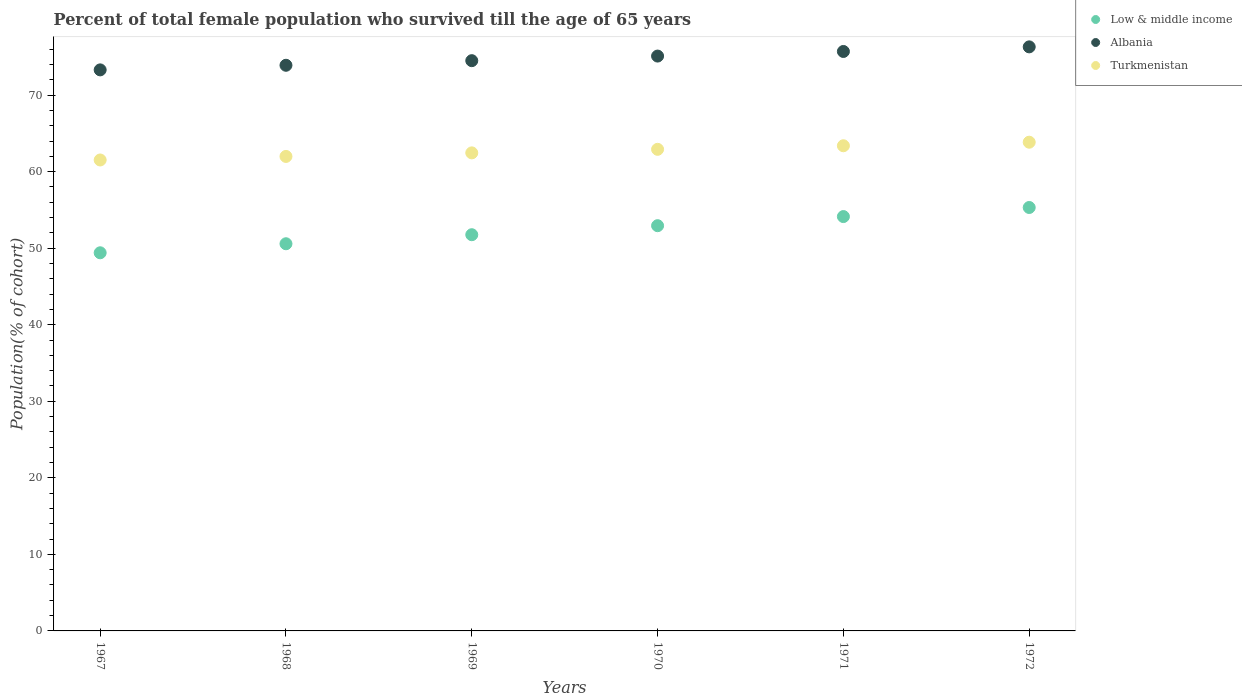How many different coloured dotlines are there?
Your answer should be compact. 3. Is the number of dotlines equal to the number of legend labels?
Make the answer very short. Yes. What is the percentage of total female population who survived till the age of 65 years in Low & middle income in 1969?
Offer a very short reply. 51.76. Across all years, what is the maximum percentage of total female population who survived till the age of 65 years in Albania?
Your answer should be compact. 76.3. Across all years, what is the minimum percentage of total female population who survived till the age of 65 years in Low & middle income?
Provide a short and direct response. 49.4. In which year was the percentage of total female population who survived till the age of 65 years in Turkmenistan maximum?
Make the answer very short. 1972. In which year was the percentage of total female population who survived till the age of 65 years in Turkmenistan minimum?
Offer a terse response. 1967. What is the total percentage of total female population who survived till the age of 65 years in Albania in the graph?
Offer a very short reply. 448.81. What is the difference between the percentage of total female population who survived till the age of 65 years in Turkmenistan in 1967 and that in 1970?
Offer a very short reply. -1.39. What is the difference between the percentage of total female population who survived till the age of 65 years in Albania in 1967 and the percentage of total female population who survived till the age of 65 years in Low & middle income in 1968?
Offer a terse response. 22.72. What is the average percentage of total female population who survived till the age of 65 years in Turkmenistan per year?
Give a very brief answer. 62.69. In the year 1967, what is the difference between the percentage of total female population who survived till the age of 65 years in Turkmenistan and percentage of total female population who survived till the age of 65 years in Albania?
Offer a terse response. -11.77. What is the ratio of the percentage of total female population who survived till the age of 65 years in Albania in 1967 to that in 1968?
Ensure brevity in your answer.  0.99. Is the percentage of total female population who survived till the age of 65 years in Turkmenistan in 1969 less than that in 1972?
Your response must be concise. Yes. Is the difference between the percentage of total female population who survived till the age of 65 years in Turkmenistan in 1970 and 1971 greater than the difference between the percentage of total female population who survived till the age of 65 years in Albania in 1970 and 1971?
Provide a short and direct response. Yes. What is the difference between the highest and the second highest percentage of total female population who survived till the age of 65 years in Albania?
Keep it short and to the point. 0.6. What is the difference between the highest and the lowest percentage of total female population who survived till the age of 65 years in Albania?
Give a very brief answer. 3.01. In how many years, is the percentage of total female population who survived till the age of 65 years in Albania greater than the average percentage of total female population who survived till the age of 65 years in Albania taken over all years?
Your answer should be very brief. 3. Is the sum of the percentage of total female population who survived till the age of 65 years in Albania in 1967 and 1968 greater than the maximum percentage of total female population who survived till the age of 65 years in Low & middle income across all years?
Ensure brevity in your answer.  Yes. Is it the case that in every year, the sum of the percentage of total female population who survived till the age of 65 years in Turkmenistan and percentage of total female population who survived till the age of 65 years in Low & middle income  is greater than the percentage of total female population who survived till the age of 65 years in Albania?
Give a very brief answer. Yes. Does the percentage of total female population who survived till the age of 65 years in Low & middle income monotonically increase over the years?
Keep it short and to the point. Yes. How many years are there in the graph?
Offer a very short reply. 6. What is the difference between two consecutive major ticks on the Y-axis?
Make the answer very short. 10. Does the graph contain grids?
Keep it short and to the point. No. How are the legend labels stacked?
Your response must be concise. Vertical. What is the title of the graph?
Your answer should be compact. Percent of total female population who survived till the age of 65 years. What is the label or title of the X-axis?
Offer a very short reply. Years. What is the label or title of the Y-axis?
Offer a very short reply. Population(% of cohort). What is the Population(% of cohort) in Low & middle income in 1967?
Your response must be concise. 49.4. What is the Population(% of cohort) in Albania in 1967?
Offer a very short reply. 73.3. What is the Population(% of cohort) of Turkmenistan in 1967?
Your answer should be very brief. 61.53. What is the Population(% of cohort) of Low & middle income in 1968?
Your answer should be very brief. 50.58. What is the Population(% of cohort) of Albania in 1968?
Provide a short and direct response. 73.9. What is the Population(% of cohort) of Turkmenistan in 1968?
Your answer should be compact. 61.99. What is the Population(% of cohort) in Low & middle income in 1969?
Make the answer very short. 51.76. What is the Population(% of cohort) in Albania in 1969?
Your answer should be very brief. 74.5. What is the Population(% of cohort) in Turkmenistan in 1969?
Your response must be concise. 62.46. What is the Population(% of cohort) in Low & middle income in 1970?
Make the answer very short. 52.94. What is the Population(% of cohort) of Albania in 1970?
Keep it short and to the point. 75.1. What is the Population(% of cohort) in Turkmenistan in 1970?
Offer a terse response. 62.92. What is the Population(% of cohort) of Low & middle income in 1971?
Make the answer very short. 54.13. What is the Population(% of cohort) of Albania in 1971?
Make the answer very short. 75.7. What is the Population(% of cohort) in Turkmenistan in 1971?
Make the answer very short. 63.38. What is the Population(% of cohort) in Low & middle income in 1972?
Offer a terse response. 55.32. What is the Population(% of cohort) in Albania in 1972?
Your answer should be compact. 76.3. What is the Population(% of cohort) in Turkmenistan in 1972?
Keep it short and to the point. 63.85. Across all years, what is the maximum Population(% of cohort) of Low & middle income?
Keep it short and to the point. 55.32. Across all years, what is the maximum Population(% of cohort) of Albania?
Offer a very short reply. 76.3. Across all years, what is the maximum Population(% of cohort) of Turkmenistan?
Your answer should be compact. 63.85. Across all years, what is the minimum Population(% of cohort) in Low & middle income?
Give a very brief answer. 49.4. Across all years, what is the minimum Population(% of cohort) in Albania?
Ensure brevity in your answer.  73.3. Across all years, what is the minimum Population(% of cohort) of Turkmenistan?
Offer a terse response. 61.53. What is the total Population(% of cohort) of Low & middle income in the graph?
Offer a terse response. 314.14. What is the total Population(% of cohort) in Albania in the graph?
Keep it short and to the point. 448.81. What is the total Population(% of cohort) of Turkmenistan in the graph?
Give a very brief answer. 376.13. What is the difference between the Population(% of cohort) of Low & middle income in 1967 and that in 1968?
Make the answer very short. -1.18. What is the difference between the Population(% of cohort) in Albania in 1967 and that in 1968?
Your response must be concise. -0.6. What is the difference between the Population(% of cohort) of Turkmenistan in 1967 and that in 1968?
Make the answer very short. -0.46. What is the difference between the Population(% of cohort) of Low & middle income in 1967 and that in 1969?
Keep it short and to the point. -2.36. What is the difference between the Population(% of cohort) of Albania in 1967 and that in 1969?
Offer a terse response. -1.2. What is the difference between the Population(% of cohort) in Turkmenistan in 1967 and that in 1969?
Give a very brief answer. -0.93. What is the difference between the Population(% of cohort) in Low & middle income in 1967 and that in 1970?
Ensure brevity in your answer.  -3.54. What is the difference between the Population(% of cohort) of Albania in 1967 and that in 1970?
Ensure brevity in your answer.  -1.8. What is the difference between the Population(% of cohort) of Turkmenistan in 1967 and that in 1970?
Keep it short and to the point. -1.39. What is the difference between the Population(% of cohort) of Low & middle income in 1967 and that in 1971?
Keep it short and to the point. -4.73. What is the difference between the Population(% of cohort) in Albania in 1967 and that in 1971?
Make the answer very short. -2.4. What is the difference between the Population(% of cohort) of Turkmenistan in 1967 and that in 1971?
Your answer should be very brief. -1.86. What is the difference between the Population(% of cohort) in Low & middle income in 1967 and that in 1972?
Make the answer very short. -5.92. What is the difference between the Population(% of cohort) in Albania in 1967 and that in 1972?
Keep it short and to the point. -3.01. What is the difference between the Population(% of cohort) in Turkmenistan in 1967 and that in 1972?
Keep it short and to the point. -2.32. What is the difference between the Population(% of cohort) of Low & middle income in 1968 and that in 1969?
Your answer should be compact. -1.18. What is the difference between the Population(% of cohort) of Albania in 1968 and that in 1969?
Your answer should be compact. -0.6. What is the difference between the Population(% of cohort) in Turkmenistan in 1968 and that in 1969?
Give a very brief answer. -0.46. What is the difference between the Population(% of cohort) of Low & middle income in 1968 and that in 1970?
Make the answer very short. -2.36. What is the difference between the Population(% of cohort) in Albania in 1968 and that in 1970?
Offer a very short reply. -1.2. What is the difference between the Population(% of cohort) of Turkmenistan in 1968 and that in 1970?
Provide a succinct answer. -0.93. What is the difference between the Population(% of cohort) in Low & middle income in 1968 and that in 1971?
Give a very brief answer. -3.55. What is the difference between the Population(% of cohort) of Albania in 1968 and that in 1971?
Keep it short and to the point. -1.8. What is the difference between the Population(% of cohort) in Turkmenistan in 1968 and that in 1971?
Your answer should be compact. -1.39. What is the difference between the Population(% of cohort) of Low & middle income in 1968 and that in 1972?
Make the answer very short. -4.74. What is the difference between the Population(% of cohort) of Albania in 1968 and that in 1972?
Your response must be concise. -2.4. What is the difference between the Population(% of cohort) in Turkmenistan in 1968 and that in 1972?
Ensure brevity in your answer.  -1.86. What is the difference between the Population(% of cohort) of Low & middle income in 1969 and that in 1970?
Offer a terse response. -1.18. What is the difference between the Population(% of cohort) of Albania in 1969 and that in 1970?
Offer a terse response. -0.6. What is the difference between the Population(% of cohort) in Turkmenistan in 1969 and that in 1970?
Your response must be concise. -0.46. What is the difference between the Population(% of cohort) of Low & middle income in 1969 and that in 1971?
Ensure brevity in your answer.  -2.37. What is the difference between the Population(% of cohort) of Albania in 1969 and that in 1971?
Provide a short and direct response. -1.2. What is the difference between the Population(% of cohort) of Turkmenistan in 1969 and that in 1971?
Offer a terse response. -0.93. What is the difference between the Population(% of cohort) of Low & middle income in 1969 and that in 1972?
Offer a very short reply. -3.56. What is the difference between the Population(% of cohort) of Albania in 1969 and that in 1972?
Your response must be concise. -1.8. What is the difference between the Population(% of cohort) in Turkmenistan in 1969 and that in 1972?
Keep it short and to the point. -1.39. What is the difference between the Population(% of cohort) of Low & middle income in 1970 and that in 1971?
Provide a short and direct response. -1.19. What is the difference between the Population(% of cohort) in Albania in 1970 and that in 1971?
Offer a terse response. -0.6. What is the difference between the Population(% of cohort) of Turkmenistan in 1970 and that in 1971?
Ensure brevity in your answer.  -0.46. What is the difference between the Population(% of cohort) in Low & middle income in 1970 and that in 1972?
Your answer should be very brief. -2.38. What is the difference between the Population(% of cohort) in Albania in 1970 and that in 1972?
Offer a very short reply. -1.2. What is the difference between the Population(% of cohort) of Turkmenistan in 1970 and that in 1972?
Your answer should be compact. -0.93. What is the difference between the Population(% of cohort) of Low & middle income in 1971 and that in 1972?
Offer a very short reply. -1.19. What is the difference between the Population(% of cohort) of Albania in 1971 and that in 1972?
Provide a short and direct response. -0.6. What is the difference between the Population(% of cohort) in Turkmenistan in 1971 and that in 1972?
Keep it short and to the point. -0.46. What is the difference between the Population(% of cohort) of Low & middle income in 1967 and the Population(% of cohort) of Albania in 1968?
Your answer should be very brief. -24.5. What is the difference between the Population(% of cohort) of Low & middle income in 1967 and the Population(% of cohort) of Turkmenistan in 1968?
Give a very brief answer. -12.59. What is the difference between the Population(% of cohort) in Albania in 1967 and the Population(% of cohort) in Turkmenistan in 1968?
Your answer should be very brief. 11.31. What is the difference between the Population(% of cohort) of Low & middle income in 1967 and the Population(% of cohort) of Albania in 1969?
Provide a short and direct response. -25.1. What is the difference between the Population(% of cohort) of Low & middle income in 1967 and the Population(% of cohort) of Turkmenistan in 1969?
Ensure brevity in your answer.  -13.05. What is the difference between the Population(% of cohort) of Albania in 1967 and the Population(% of cohort) of Turkmenistan in 1969?
Give a very brief answer. 10.84. What is the difference between the Population(% of cohort) in Low & middle income in 1967 and the Population(% of cohort) in Albania in 1970?
Offer a very short reply. -25.7. What is the difference between the Population(% of cohort) of Low & middle income in 1967 and the Population(% of cohort) of Turkmenistan in 1970?
Ensure brevity in your answer.  -13.52. What is the difference between the Population(% of cohort) of Albania in 1967 and the Population(% of cohort) of Turkmenistan in 1970?
Provide a succinct answer. 10.38. What is the difference between the Population(% of cohort) in Low & middle income in 1967 and the Population(% of cohort) in Albania in 1971?
Offer a terse response. -26.3. What is the difference between the Population(% of cohort) in Low & middle income in 1967 and the Population(% of cohort) in Turkmenistan in 1971?
Keep it short and to the point. -13.98. What is the difference between the Population(% of cohort) in Albania in 1967 and the Population(% of cohort) in Turkmenistan in 1971?
Your answer should be compact. 9.91. What is the difference between the Population(% of cohort) of Low & middle income in 1967 and the Population(% of cohort) of Albania in 1972?
Offer a very short reply. -26.9. What is the difference between the Population(% of cohort) of Low & middle income in 1967 and the Population(% of cohort) of Turkmenistan in 1972?
Keep it short and to the point. -14.45. What is the difference between the Population(% of cohort) in Albania in 1967 and the Population(% of cohort) in Turkmenistan in 1972?
Offer a terse response. 9.45. What is the difference between the Population(% of cohort) of Low & middle income in 1968 and the Population(% of cohort) of Albania in 1969?
Offer a terse response. -23.92. What is the difference between the Population(% of cohort) of Low & middle income in 1968 and the Population(% of cohort) of Turkmenistan in 1969?
Give a very brief answer. -11.87. What is the difference between the Population(% of cohort) of Albania in 1968 and the Population(% of cohort) of Turkmenistan in 1969?
Your answer should be very brief. 11.44. What is the difference between the Population(% of cohort) in Low & middle income in 1968 and the Population(% of cohort) in Albania in 1970?
Your response must be concise. -24.52. What is the difference between the Population(% of cohort) in Low & middle income in 1968 and the Population(% of cohort) in Turkmenistan in 1970?
Make the answer very short. -12.34. What is the difference between the Population(% of cohort) of Albania in 1968 and the Population(% of cohort) of Turkmenistan in 1970?
Provide a succinct answer. 10.98. What is the difference between the Population(% of cohort) of Low & middle income in 1968 and the Population(% of cohort) of Albania in 1971?
Keep it short and to the point. -25.12. What is the difference between the Population(% of cohort) in Low & middle income in 1968 and the Population(% of cohort) in Turkmenistan in 1971?
Offer a very short reply. -12.8. What is the difference between the Population(% of cohort) in Albania in 1968 and the Population(% of cohort) in Turkmenistan in 1971?
Offer a terse response. 10.52. What is the difference between the Population(% of cohort) in Low & middle income in 1968 and the Population(% of cohort) in Albania in 1972?
Give a very brief answer. -25.72. What is the difference between the Population(% of cohort) in Low & middle income in 1968 and the Population(% of cohort) in Turkmenistan in 1972?
Your answer should be compact. -13.27. What is the difference between the Population(% of cohort) in Albania in 1968 and the Population(% of cohort) in Turkmenistan in 1972?
Provide a short and direct response. 10.05. What is the difference between the Population(% of cohort) in Low & middle income in 1969 and the Population(% of cohort) in Albania in 1970?
Your answer should be compact. -23.34. What is the difference between the Population(% of cohort) in Low & middle income in 1969 and the Population(% of cohort) in Turkmenistan in 1970?
Provide a succinct answer. -11.16. What is the difference between the Population(% of cohort) of Albania in 1969 and the Population(% of cohort) of Turkmenistan in 1970?
Offer a terse response. 11.58. What is the difference between the Population(% of cohort) in Low & middle income in 1969 and the Population(% of cohort) in Albania in 1971?
Offer a terse response. -23.94. What is the difference between the Population(% of cohort) of Low & middle income in 1969 and the Population(% of cohort) of Turkmenistan in 1971?
Keep it short and to the point. -11.62. What is the difference between the Population(% of cohort) in Albania in 1969 and the Population(% of cohort) in Turkmenistan in 1971?
Make the answer very short. 11.12. What is the difference between the Population(% of cohort) of Low & middle income in 1969 and the Population(% of cohort) of Albania in 1972?
Offer a terse response. -24.54. What is the difference between the Population(% of cohort) in Low & middle income in 1969 and the Population(% of cohort) in Turkmenistan in 1972?
Your response must be concise. -12.09. What is the difference between the Population(% of cohort) of Albania in 1969 and the Population(% of cohort) of Turkmenistan in 1972?
Offer a very short reply. 10.65. What is the difference between the Population(% of cohort) in Low & middle income in 1970 and the Population(% of cohort) in Albania in 1971?
Make the answer very short. -22.76. What is the difference between the Population(% of cohort) of Low & middle income in 1970 and the Population(% of cohort) of Turkmenistan in 1971?
Provide a succinct answer. -10.44. What is the difference between the Population(% of cohort) of Albania in 1970 and the Population(% of cohort) of Turkmenistan in 1971?
Your answer should be compact. 11.72. What is the difference between the Population(% of cohort) of Low & middle income in 1970 and the Population(% of cohort) of Albania in 1972?
Keep it short and to the point. -23.36. What is the difference between the Population(% of cohort) in Low & middle income in 1970 and the Population(% of cohort) in Turkmenistan in 1972?
Ensure brevity in your answer.  -10.91. What is the difference between the Population(% of cohort) of Albania in 1970 and the Population(% of cohort) of Turkmenistan in 1972?
Provide a short and direct response. 11.25. What is the difference between the Population(% of cohort) of Low & middle income in 1971 and the Population(% of cohort) of Albania in 1972?
Your answer should be compact. -22.17. What is the difference between the Population(% of cohort) of Low & middle income in 1971 and the Population(% of cohort) of Turkmenistan in 1972?
Ensure brevity in your answer.  -9.72. What is the difference between the Population(% of cohort) of Albania in 1971 and the Population(% of cohort) of Turkmenistan in 1972?
Offer a terse response. 11.85. What is the average Population(% of cohort) of Low & middle income per year?
Provide a short and direct response. 52.36. What is the average Population(% of cohort) of Albania per year?
Offer a very short reply. 74.8. What is the average Population(% of cohort) in Turkmenistan per year?
Your response must be concise. 62.69. In the year 1967, what is the difference between the Population(% of cohort) of Low & middle income and Population(% of cohort) of Albania?
Offer a very short reply. -23.9. In the year 1967, what is the difference between the Population(% of cohort) of Low & middle income and Population(% of cohort) of Turkmenistan?
Keep it short and to the point. -12.12. In the year 1967, what is the difference between the Population(% of cohort) of Albania and Population(% of cohort) of Turkmenistan?
Keep it short and to the point. 11.77. In the year 1968, what is the difference between the Population(% of cohort) in Low & middle income and Population(% of cohort) in Albania?
Make the answer very short. -23.32. In the year 1968, what is the difference between the Population(% of cohort) of Low & middle income and Population(% of cohort) of Turkmenistan?
Offer a terse response. -11.41. In the year 1968, what is the difference between the Population(% of cohort) of Albania and Population(% of cohort) of Turkmenistan?
Make the answer very short. 11.91. In the year 1969, what is the difference between the Population(% of cohort) of Low & middle income and Population(% of cohort) of Albania?
Keep it short and to the point. -22.74. In the year 1969, what is the difference between the Population(% of cohort) of Low & middle income and Population(% of cohort) of Turkmenistan?
Provide a short and direct response. -10.69. In the year 1969, what is the difference between the Population(% of cohort) of Albania and Population(% of cohort) of Turkmenistan?
Provide a succinct answer. 12.05. In the year 1970, what is the difference between the Population(% of cohort) of Low & middle income and Population(% of cohort) of Albania?
Offer a very short reply. -22.16. In the year 1970, what is the difference between the Population(% of cohort) of Low & middle income and Population(% of cohort) of Turkmenistan?
Offer a terse response. -9.98. In the year 1970, what is the difference between the Population(% of cohort) of Albania and Population(% of cohort) of Turkmenistan?
Provide a short and direct response. 12.18. In the year 1971, what is the difference between the Population(% of cohort) in Low & middle income and Population(% of cohort) in Albania?
Offer a very short reply. -21.57. In the year 1971, what is the difference between the Population(% of cohort) of Low & middle income and Population(% of cohort) of Turkmenistan?
Give a very brief answer. -9.25. In the year 1971, what is the difference between the Population(% of cohort) of Albania and Population(% of cohort) of Turkmenistan?
Offer a very short reply. 12.32. In the year 1972, what is the difference between the Population(% of cohort) of Low & middle income and Population(% of cohort) of Albania?
Ensure brevity in your answer.  -20.99. In the year 1972, what is the difference between the Population(% of cohort) of Low & middle income and Population(% of cohort) of Turkmenistan?
Ensure brevity in your answer.  -8.53. In the year 1972, what is the difference between the Population(% of cohort) in Albania and Population(% of cohort) in Turkmenistan?
Your response must be concise. 12.46. What is the ratio of the Population(% of cohort) of Low & middle income in 1967 to that in 1968?
Provide a short and direct response. 0.98. What is the ratio of the Population(% of cohort) in Albania in 1967 to that in 1968?
Provide a short and direct response. 0.99. What is the ratio of the Population(% of cohort) of Low & middle income in 1967 to that in 1969?
Keep it short and to the point. 0.95. What is the ratio of the Population(% of cohort) of Albania in 1967 to that in 1969?
Make the answer very short. 0.98. What is the ratio of the Population(% of cohort) in Turkmenistan in 1967 to that in 1969?
Offer a terse response. 0.99. What is the ratio of the Population(% of cohort) in Low & middle income in 1967 to that in 1970?
Offer a very short reply. 0.93. What is the ratio of the Population(% of cohort) in Turkmenistan in 1967 to that in 1970?
Your answer should be very brief. 0.98. What is the ratio of the Population(% of cohort) in Low & middle income in 1967 to that in 1971?
Your answer should be compact. 0.91. What is the ratio of the Population(% of cohort) in Albania in 1967 to that in 1971?
Give a very brief answer. 0.97. What is the ratio of the Population(% of cohort) of Turkmenistan in 1967 to that in 1971?
Your answer should be very brief. 0.97. What is the ratio of the Population(% of cohort) in Low & middle income in 1967 to that in 1972?
Keep it short and to the point. 0.89. What is the ratio of the Population(% of cohort) of Albania in 1967 to that in 1972?
Provide a succinct answer. 0.96. What is the ratio of the Population(% of cohort) in Turkmenistan in 1967 to that in 1972?
Make the answer very short. 0.96. What is the ratio of the Population(% of cohort) of Low & middle income in 1968 to that in 1969?
Offer a terse response. 0.98. What is the ratio of the Population(% of cohort) of Albania in 1968 to that in 1969?
Provide a succinct answer. 0.99. What is the ratio of the Population(% of cohort) of Turkmenistan in 1968 to that in 1969?
Your answer should be compact. 0.99. What is the ratio of the Population(% of cohort) of Low & middle income in 1968 to that in 1970?
Your answer should be very brief. 0.96. What is the ratio of the Population(% of cohort) in Turkmenistan in 1968 to that in 1970?
Keep it short and to the point. 0.99. What is the ratio of the Population(% of cohort) of Low & middle income in 1968 to that in 1971?
Make the answer very short. 0.93. What is the ratio of the Population(% of cohort) in Albania in 1968 to that in 1971?
Provide a succinct answer. 0.98. What is the ratio of the Population(% of cohort) of Low & middle income in 1968 to that in 1972?
Offer a terse response. 0.91. What is the ratio of the Population(% of cohort) in Albania in 1968 to that in 1972?
Give a very brief answer. 0.97. What is the ratio of the Population(% of cohort) of Turkmenistan in 1968 to that in 1972?
Your response must be concise. 0.97. What is the ratio of the Population(% of cohort) of Low & middle income in 1969 to that in 1970?
Your answer should be very brief. 0.98. What is the ratio of the Population(% of cohort) of Albania in 1969 to that in 1970?
Offer a terse response. 0.99. What is the ratio of the Population(% of cohort) of Low & middle income in 1969 to that in 1971?
Offer a very short reply. 0.96. What is the ratio of the Population(% of cohort) of Albania in 1969 to that in 1971?
Your response must be concise. 0.98. What is the ratio of the Population(% of cohort) in Turkmenistan in 1969 to that in 1971?
Provide a short and direct response. 0.99. What is the ratio of the Population(% of cohort) of Low & middle income in 1969 to that in 1972?
Ensure brevity in your answer.  0.94. What is the ratio of the Population(% of cohort) in Albania in 1969 to that in 1972?
Keep it short and to the point. 0.98. What is the ratio of the Population(% of cohort) of Turkmenistan in 1969 to that in 1972?
Provide a succinct answer. 0.98. What is the ratio of the Population(% of cohort) of Albania in 1970 to that in 1971?
Keep it short and to the point. 0.99. What is the ratio of the Population(% of cohort) in Turkmenistan in 1970 to that in 1971?
Keep it short and to the point. 0.99. What is the ratio of the Population(% of cohort) of Low & middle income in 1970 to that in 1972?
Your answer should be very brief. 0.96. What is the ratio of the Population(% of cohort) of Albania in 1970 to that in 1972?
Give a very brief answer. 0.98. What is the ratio of the Population(% of cohort) of Turkmenistan in 1970 to that in 1972?
Give a very brief answer. 0.99. What is the ratio of the Population(% of cohort) in Low & middle income in 1971 to that in 1972?
Keep it short and to the point. 0.98. What is the ratio of the Population(% of cohort) of Turkmenistan in 1971 to that in 1972?
Your answer should be very brief. 0.99. What is the difference between the highest and the second highest Population(% of cohort) in Low & middle income?
Make the answer very short. 1.19. What is the difference between the highest and the second highest Population(% of cohort) of Albania?
Make the answer very short. 0.6. What is the difference between the highest and the second highest Population(% of cohort) in Turkmenistan?
Give a very brief answer. 0.46. What is the difference between the highest and the lowest Population(% of cohort) of Low & middle income?
Your response must be concise. 5.92. What is the difference between the highest and the lowest Population(% of cohort) of Albania?
Your answer should be compact. 3.01. What is the difference between the highest and the lowest Population(% of cohort) of Turkmenistan?
Provide a succinct answer. 2.32. 